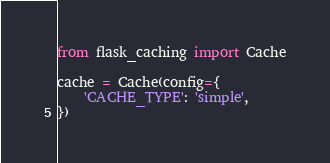Convert code to text. <code><loc_0><loc_0><loc_500><loc_500><_Python_>from flask_caching import Cache

cache = Cache(config={
    'CACHE_TYPE': 'simple',
})
</code> 